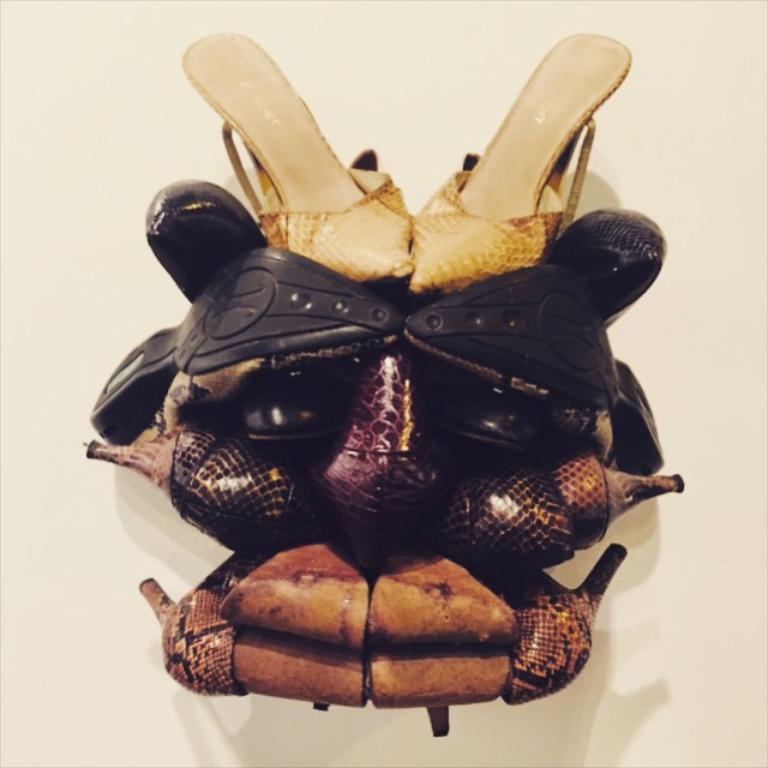What type of objects can be seen in the image? There are pairs of footwear in the image. How are the footwear arranged in the image? The footwear are arranged one above the other in an architectural manner. What is the purpose of the sink in the image? There is no sink present in the image; it only features pairs of footwear arranged in an architectural manner. 